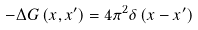Convert formula to latex. <formula><loc_0><loc_0><loc_500><loc_500>- \Delta G \left ( x , x ^ { \prime } \right ) = 4 \pi ^ { 2 } \delta \left ( x - x ^ { \prime } \right )</formula> 